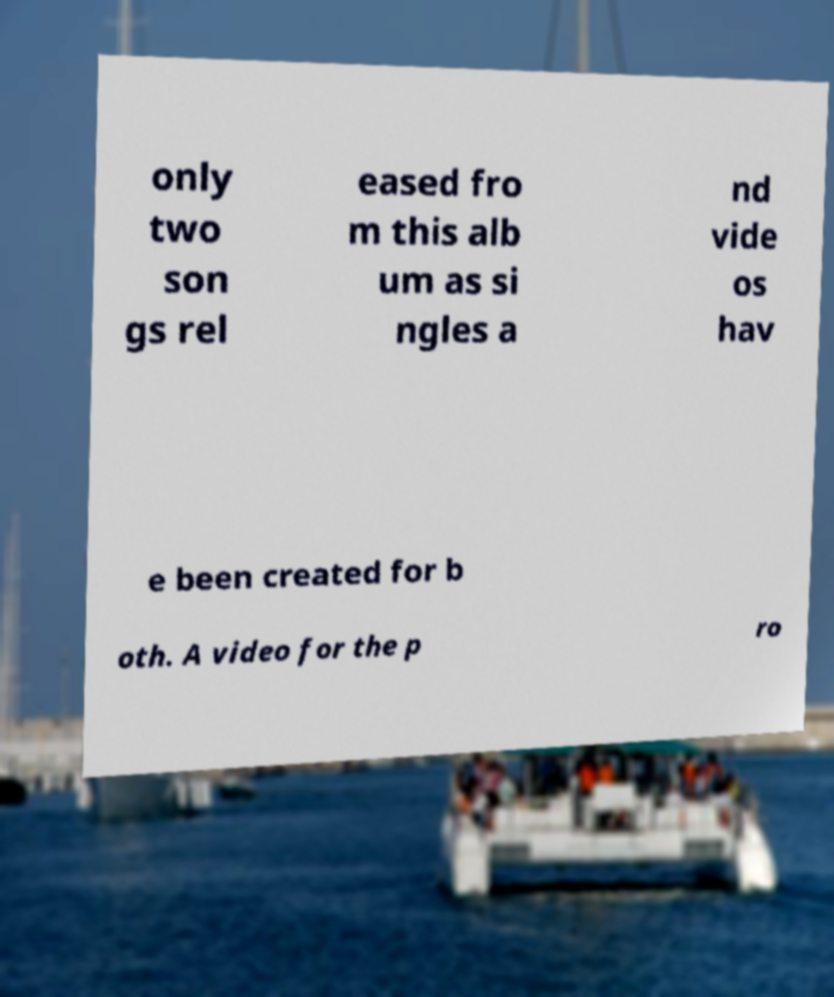I need the written content from this picture converted into text. Can you do that? only two son gs rel eased fro m this alb um as si ngles a nd vide os hav e been created for b oth. A video for the p ro 